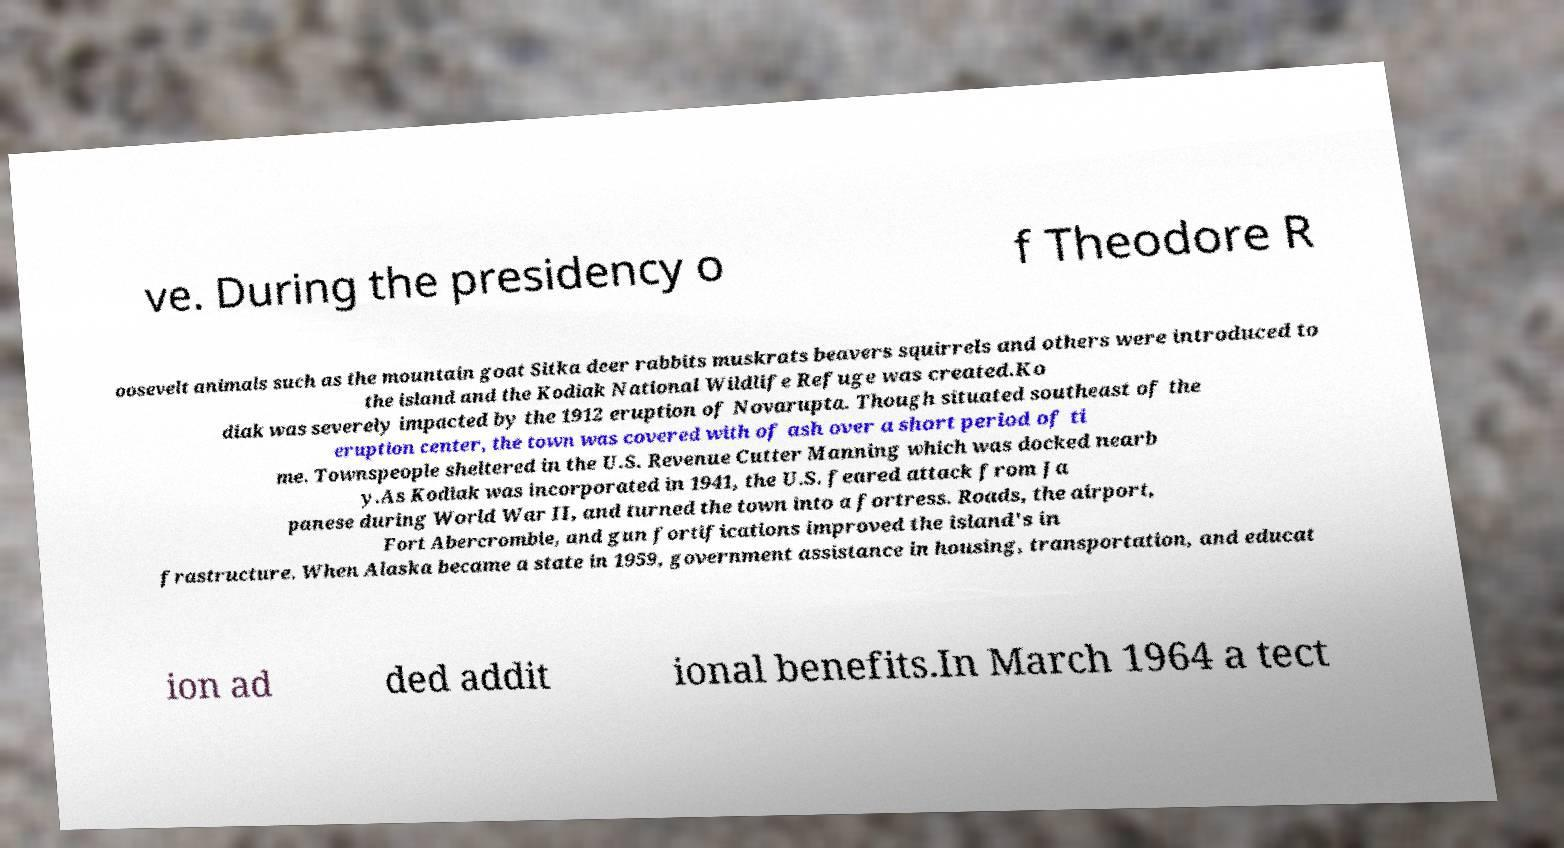Please read and relay the text visible in this image. What does it say? ve. During the presidency o f Theodore R oosevelt animals such as the mountain goat Sitka deer rabbits muskrats beavers squirrels and others were introduced to the island and the Kodiak National Wildlife Refuge was created.Ko diak was severely impacted by the 1912 eruption of Novarupta. Though situated southeast of the eruption center, the town was covered with of ash over a short period of ti me. Townspeople sheltered in the U.S. Revenue Cutter Manning which was docked nearb y.As Kodiak was incorporated in 1941, the U.S. feared attack from Ja panese during World War II, and turned the town into a fortress. Roads, the airport, Fort Abercrombie, and gun fortifications improved the island's in frastructure. When Alaska became a state in 1959, government assistance in housing, transportation, and educat ion ad ded addit ional benefits.In March 1964 a tect 